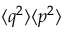Convert formula to latex. <formula><loc_0><loc_0><loc_500><loc_500>\langle q ^ { 2 } \rangle \langle p ^ { 2 } \rangle</formula> 